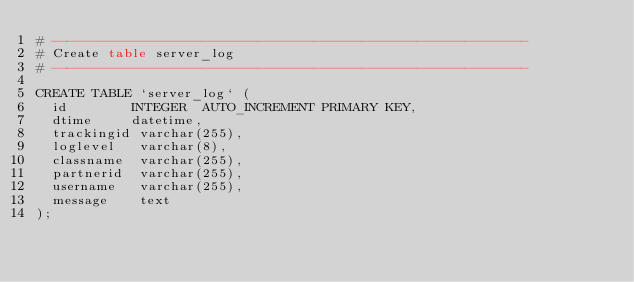Convert code to text. <code><loc_0><loc_0><loc_500><loc_500><_SQL_># ------------------------------------------------------------
# Create table server_log
# ------------------------------------------------------------

CREATE TABLE `server_log` (
  id        INTEGER  AUTO_INCREMENT PRIMARY KEY,
  dtime     datetime,
  trackingid varchar(255),
  loglevel   varchar(8),
  classname  varchar(255),
  partnerid  varchar(255),
  username   varchar(255),
  message    text
);
</code> 